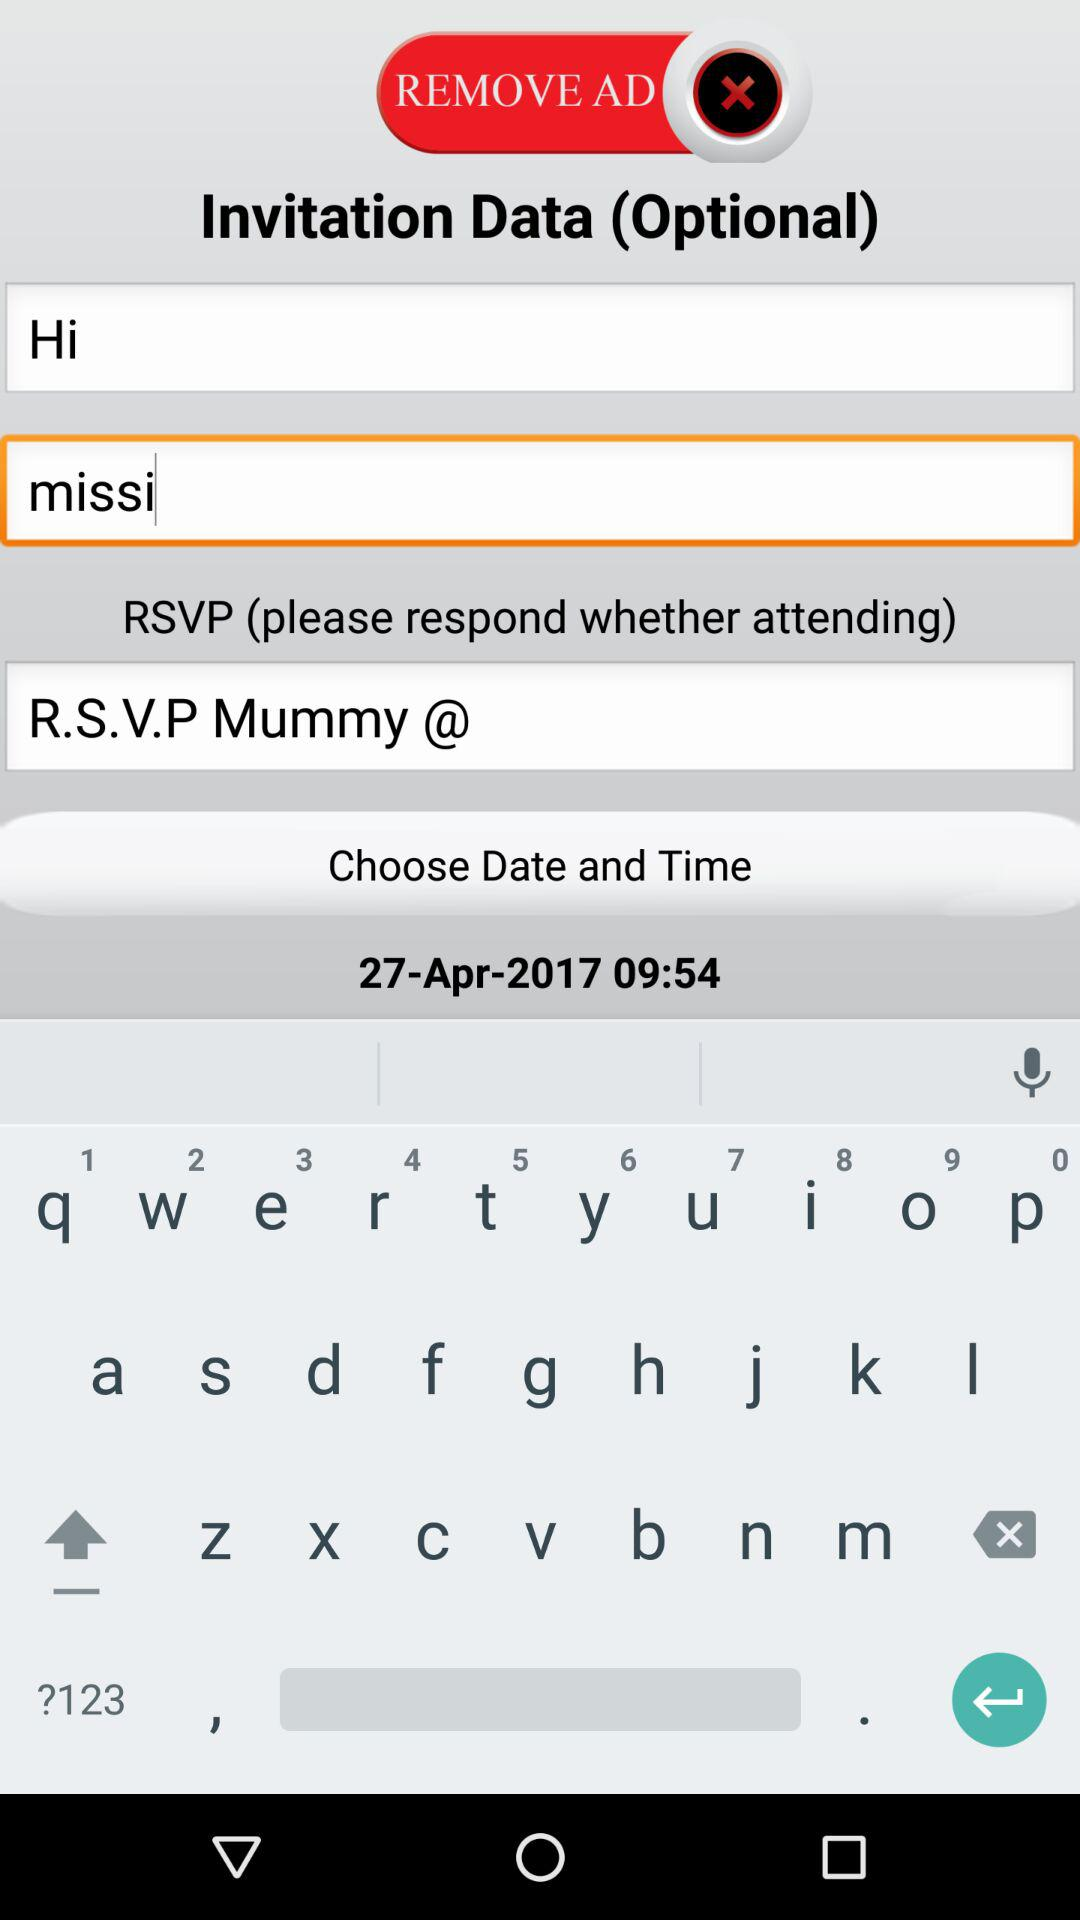What's the name? The name is "missi". 